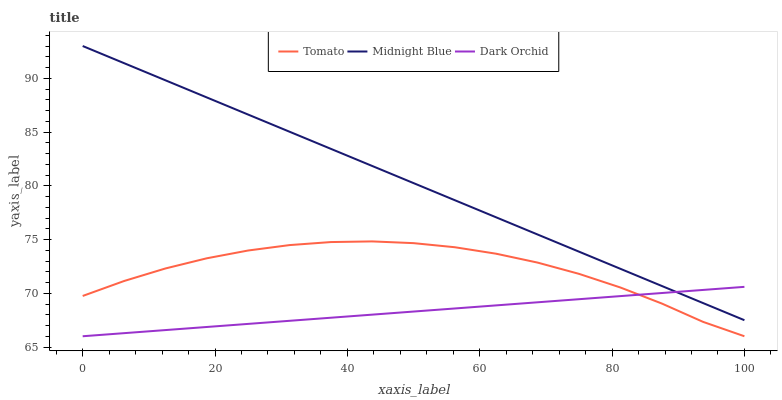Does Dark Orchid have the minimum area under the curve?
Answer yes or no. Yes. Does Midnight Blue have the maximum area under the curve?
Answer yes or no. Yes. Does Midnight Blue have the minimum area under the curve?
Answer yes or no. No. Does Dark Orchid have the maximum area under the curve?
Answer yes or no. No. Is Midnight Blue the smoothest?
Answer yes or no. Yes. Is Tomato the roughest?
Answer yes or no. Yes. Is Dark Orchid the smoothest?
Answer yes or no. No. Is Dark Orchid the roughest?
Answer yes or no. No. Does Tomato have the lowest value?
Answer yes or no. Yes. Does Midnight Blue have the lowest value?
Answer yes or no. No. Does Midnight Blue have the highest value?
Answer yes or no. Yes. Does Dark Orchid have the highest value?
Answer yes or no. No. Is Tomato less than Midnight Blue?
Answer yes or no. Yes. Is Midnight Blue greater than Tomato?
Answer yes or no. Yes. Does Midnight Blue intersect Dark Orchid?
Answer yes or no. Yes. Is Midnight Blue less than Dark Orchid?
Answer yes or no. No. Is Midnight Blue greater than Dark Orchid?
Answer yes or no. No. Does Tomato intersect Midnight Blue?
Answer yes or no. No. 